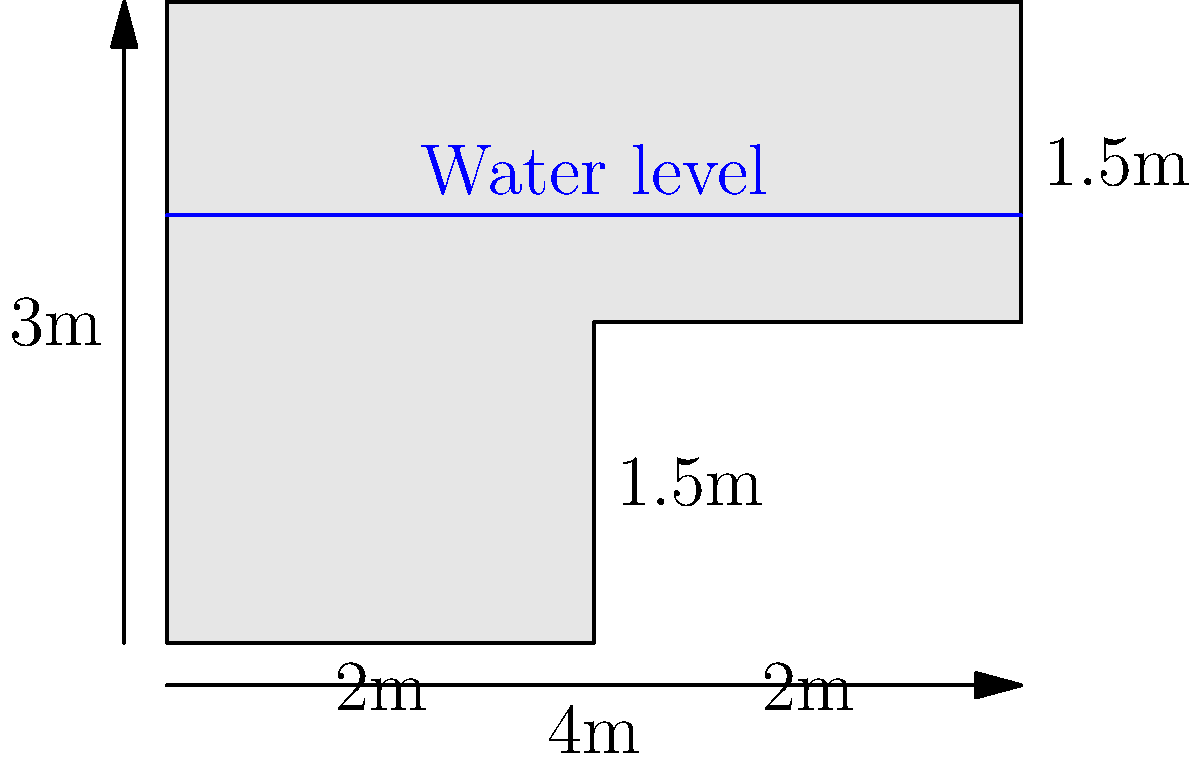A rural community in Äyşiyaz needs to calculate the volume of their irregularly shaped water storage tank. The tank has a length of 4m and a height of 3m, with a step-like shape as shown in the diagram. If the water level is at 2m height, what is the volume of water in the tank? (Assume the tank has a uniform width of 1m) To calculate the volume of water in the irregularly shaped tank, we need to break it down into rectangular sections and sum their volumes. Let's follow these steps:

1. Identify the sections:
   - Section 1: 2m long, 2m high
   - Section 2: 2m long, 1.5m high (water fills up to 2m)

2. Calculate the volume of water in each section:
   - Volume of Section 1: $V_1 = 2m \times 2m \times 1m = 4m^3$
   - Volume of Section 2: $V_2 = 2m \times 2m \times 1m = 4m^3$

3. Sum up the volumes:
   Total volume = $V_1 + V_2 = 4m^3 + 4m^3 = 8m^3$

Therefore, the volume of water in the tank is 8 cubic meters.
Answer: $8m^3$ 